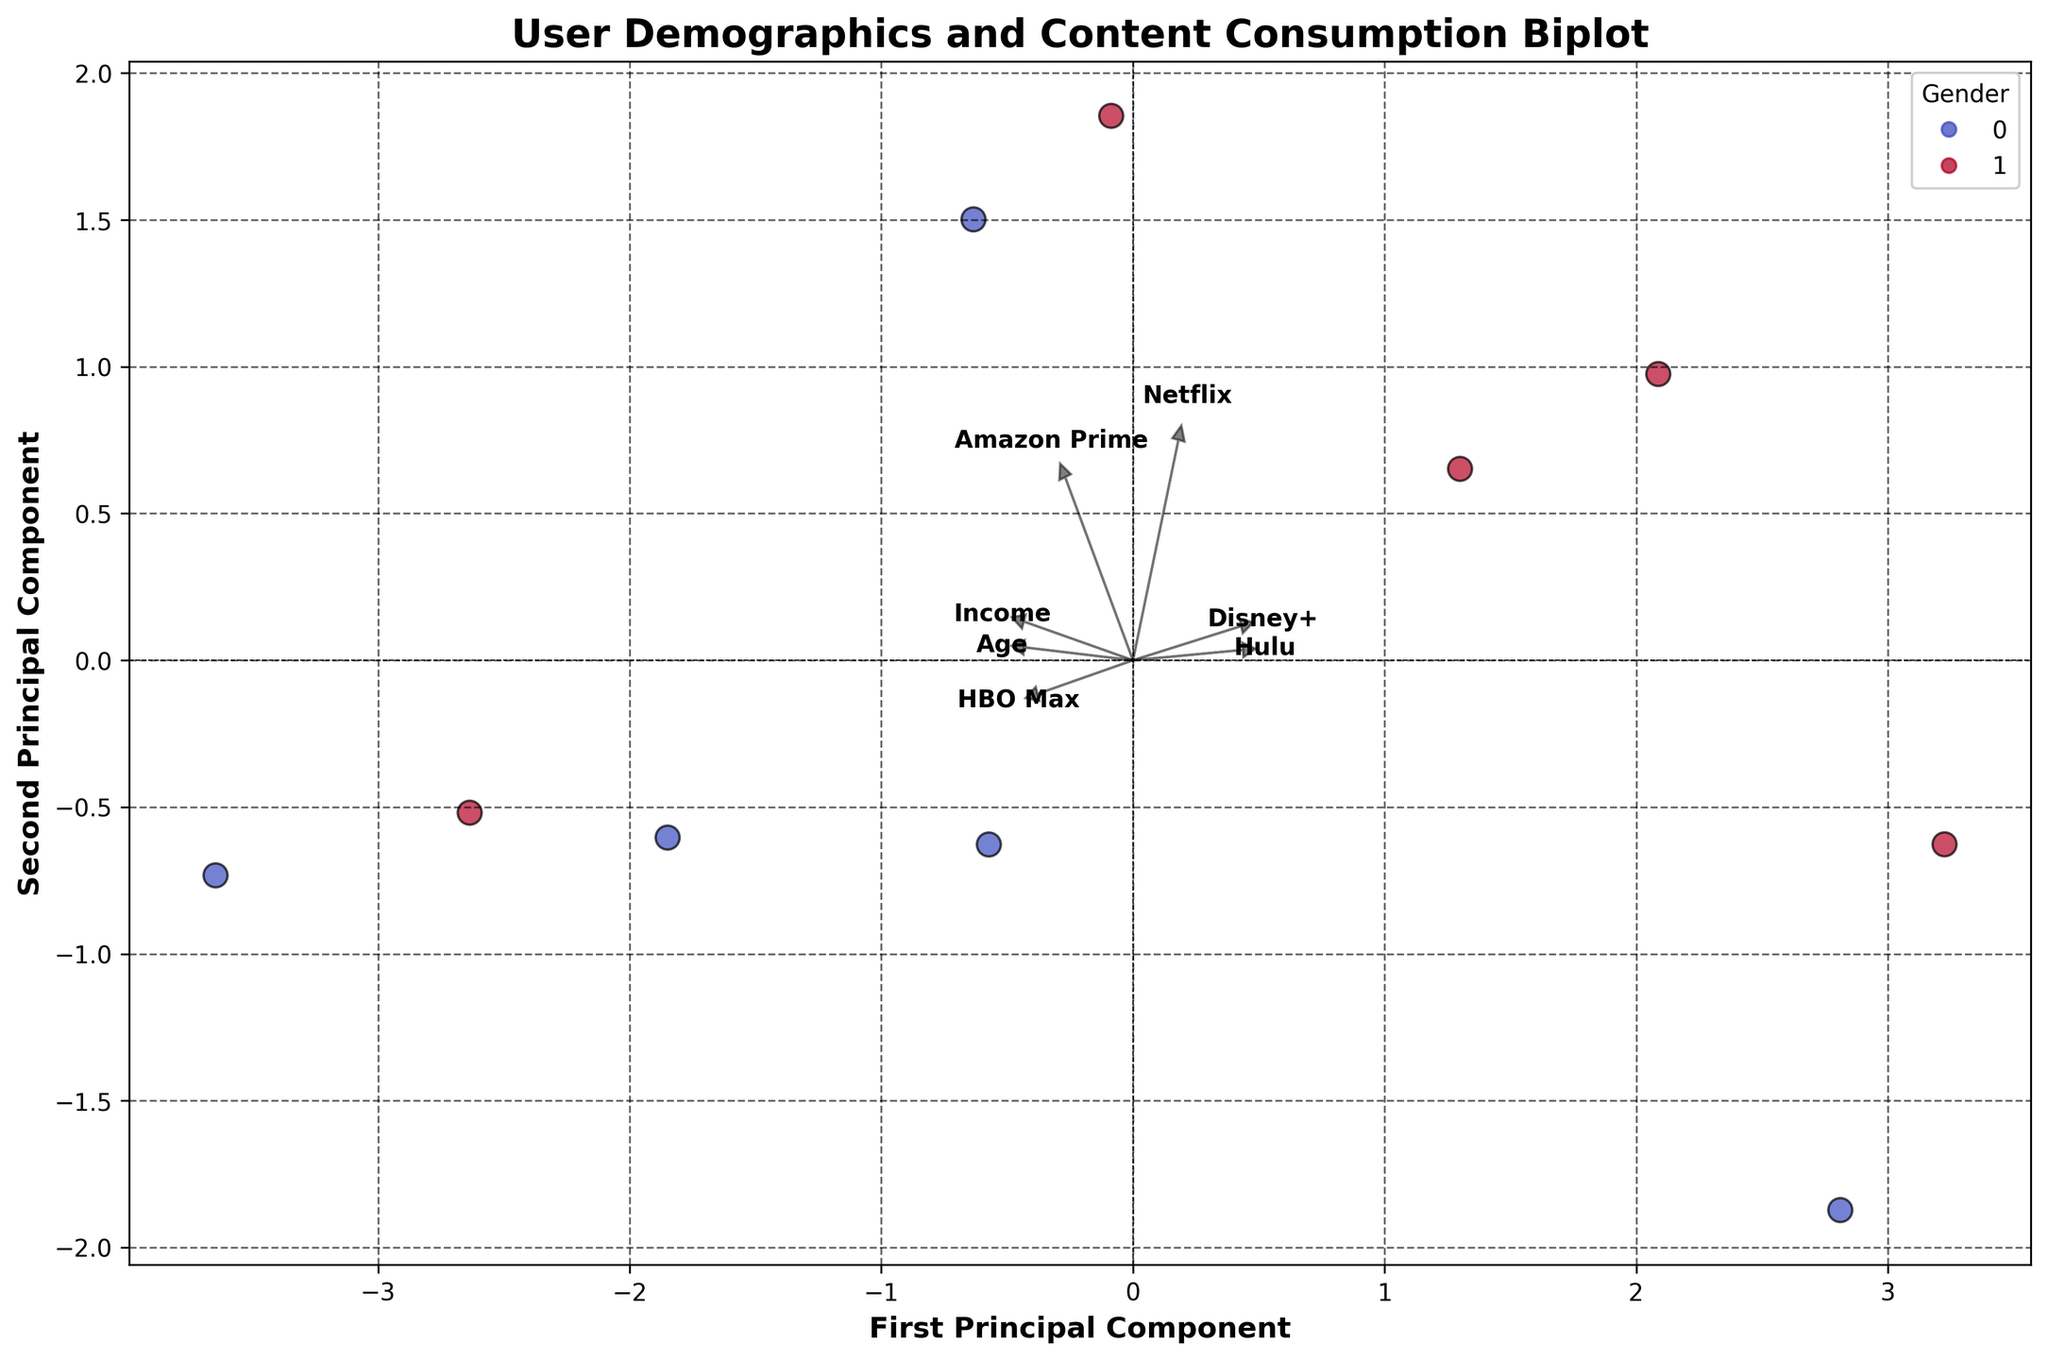What's the title of the biplot? The title of the figure is visible at the top-center part of the plot.
Answer: User Demographics and Content Consumption Biplot How many principal components are displayed on the biplot? The biplot has two axes labeled "First Principal Component" and "Second Principal Component" indicating two principal components.
Answer: Two What colors are used to represent different genders in the scatter plot? The legend on the plot describes the color mapping: 'Male' is represented by one color and 'Female' by another.
Answer: Male: one color, Female: another color (specific colors depend on the figure) Which feature vector has the highest loading on the second principal component? Checking the length of the arrows reaching towards the second principal component axis, the feature with the longest vector indicates the highest loading.
Answer: HBO Max Which feature vector is closest to the First Principal Component axis but not aligned with it? By observing the vectors and their alignments, identify the vector that is closest to the First Principal Component axis without overlapping it.
Answer: Disney+ Are there more male or female users represented in the plot? Counting the number of data points (scatter points) that are color-coded per the legend. Compare quantities to see which gender is more represented.
Answer: Female Is the feature "Income" more aligned with the First or Second Principal Component? Look at the direction of the "Income" feature vector relative to both the First and Second Principal Components.
Answer: First Principal Component How would you describe the relationship between age and content consumption on HBO Max? Find the "Age" and "HBO Max" vectors. Since HBO Max has a high loading on the second component, the direction vectors point out mutual relationships. Evaluate whether they point the same (positive correlation) or opposite directions.
Answer: Positive correlation Which feature seems to have the least impact on the First Principal Component? The size of the vector along the First Principal Component shows the impact. The shorter, the smaller the impact.
Answer: Disney+ Based on the biplot, which gender seems to have higher usage of Netflix? Check the cluster of data points labeled 'Netflix' and see if there's a noticeable gathering of points from one gender closer to this cluster.
Answer: Female Which features are more likely to be related to each other based on the PCA components? The vectors that point in the similar direction or are closely spaced are indicative of related features.
Answer: Netflix and Documentary 